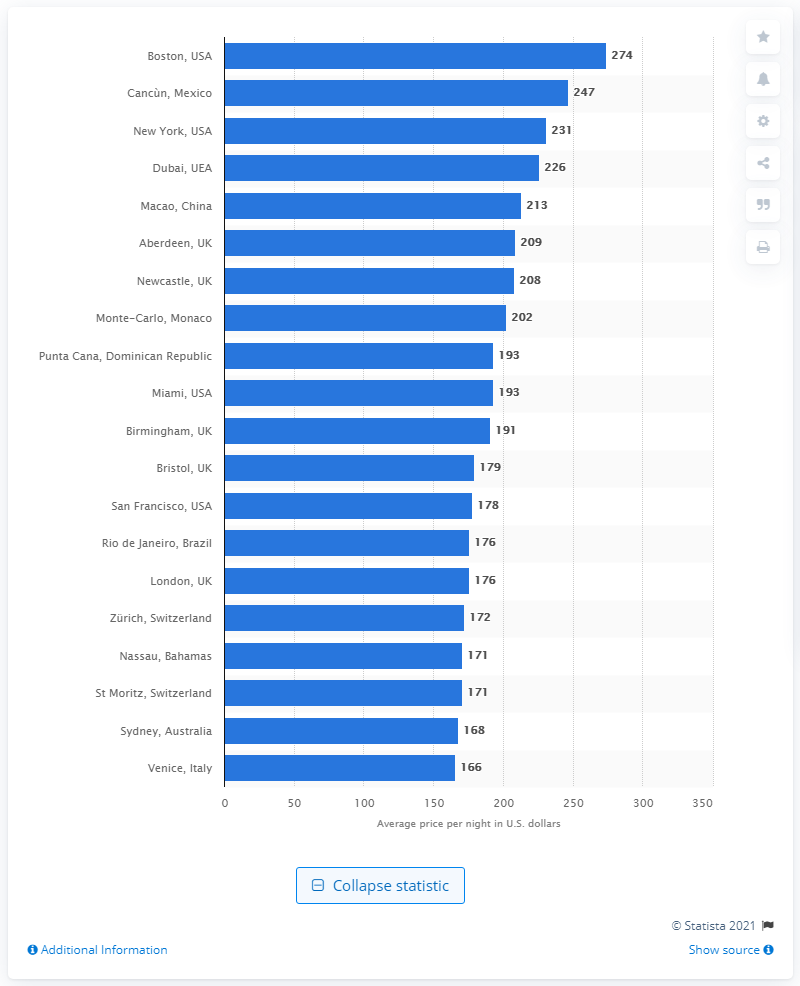Indicate a few pertinent items in this graphic. The average cost of a night in Boston is approximately $274. 